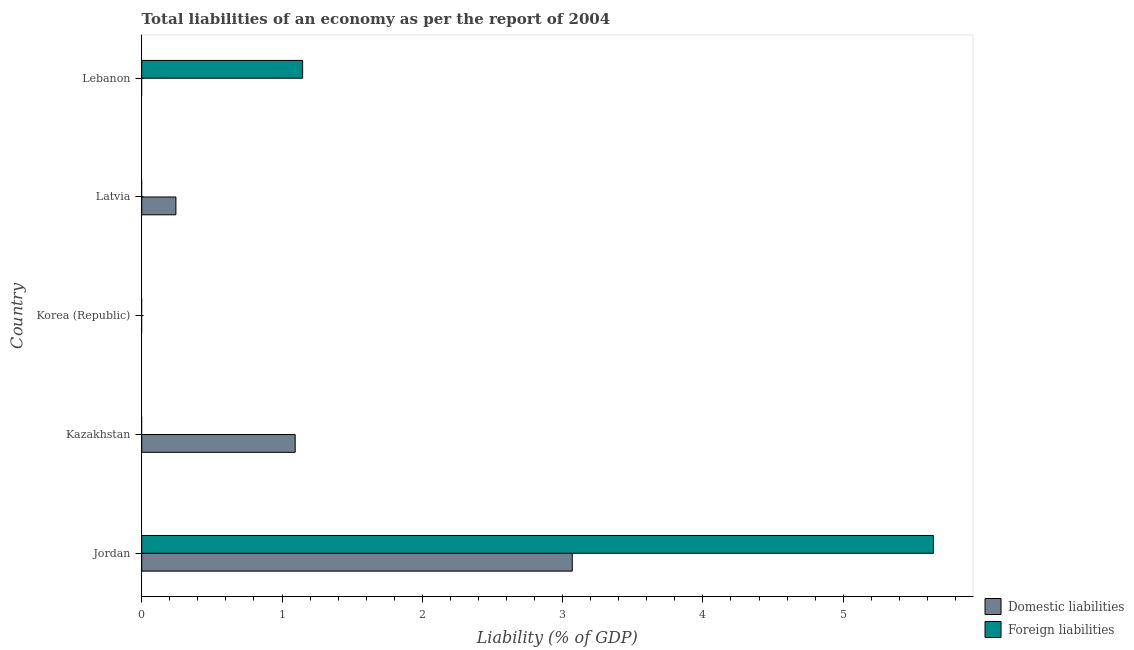How many different coloured bars are there?
Your answer should be very brief. 2. How many bars are there on the 4th tick from the top?
Make the answer very short. 1. What is the incurrence of foreign liabilities in Kazakhstan?
Offer a very short reply. 0. Across all countries, what is the maximum incurrence of foreign liabilities?
Offer a terse response. 5.64. In which country was the incurrence of domestic liabilities maximum?
Keep it short and to the point. Jordan. What is the total incurrence of foreign liabilities in the graph?
Your answer should be compact. 6.79. What is the difference between the incurrence of domestic liabilities in Jordan and that in Kazakhstan?
Your answer should be very brief. 1.98. What is the difference between the incurrence of domestic liabilities in Latvia and the incurrence of foreign liabilities in Kazakhstan?
Ensure brevity in your answer.  0.24. What is the average incurrence of foreign liabilities per country?
Provide a succinct answer. 1.36. What is the difference between the highest and the second highest incurrence of domestic liabilities?
Your answer should be very brief. 1.98. What is the difference between the highest and the lowest incurrence of foreign liabilities?
Provide a short and direct response. 5.64. In how many countries, is the incurrence of domestic liabilities greater than the average incurrence of domestic liabilities taken over all countries?
Your response must be concise. 2. How many bars are there?
Ensure brevity in your answer.  5. What is the difference between two consecutive major ticks on the X-axis?
Make the answer very short. 1. Are the values on the major ticks of X-axis written in scientific E-notation?
Make the answer very short. No. How are the legend labels stacked?
Your answer should be very brief. Vertical. What is the title of the graph?
Provide a short and direct response. Total liabilities of an economy as per the report of 2004. What is the label or title of the X-axis?
Offer a very short reply. Liability (% of GDP). What is the label or title of the Y-axis?
Provide a short and direct response. Country. What is the Liability (% of GDP) in Domestic liabilities in Jordan?
Provide a short and direct response. 3.07. What is the Liability (% of GDP) of Foreign liabilities in Jordan?
Provide a succinct answer. 5.64. What is the Liability (% of GDP) in Domestic liabilities in Kazakhstan?
Make the answer very short. 1.09. What is the Liability (% of GDP) of Domestic liabilities in Latvia?
Your response must be concise. 0.24. What is the Liability (% of GDP) of Foreign liabilities in Latvia?
Keep it short and to the point. 0. What is the Liability (% of GDP) in Domestic liabilities in Lebanon?
Ensure brevity in your answer.  0. What is the Liability (% of GDP) of Foreign liabilities in Lebanon?
Give a very brief answer. 1.15. Across all countries, what is the maximum Liability (% of GDP) of Domestic liabilities?
Provide a short and direct response. 3.07. Across all countries, what is the maximum Liability (% of GDP) of Foreign liabilities?
Your answer should be very brief. 5.64. What is the total Liability (% of GDP) in Domestic liabilities in the graph?
Offer a terse response. 4.41. What is the total Liability (% of GDP) in Foreign liabilities in the graph?
Your answer should be compact. 6.79. What is the difference between the Liability (% of GDP) of Domestic liabilities in Jordan and that in Kazakhstan?
Keep it short and to the point. 1.98. What is the difference between the Liability (% of GDP) of Domestic liabilities in Jordan and that in Latvia?
Your response must be concise. 2.83. What is the difference between the Liability (% of GDP) in Foreign liabilities in Jordan and that in Lebanon?
Provide a short and direct response. 4.5. What is the difference between the Liability (% of GDP) of Domestic liabilities in Kazakhstan and that in Latvia?
Provide a succinct answer. 0.85. What is the difference between the Liability (% of GDP) in Domestic liabilities in Jordan and the Liability (% of GDP) in Foreign liabilities in Lebanon?
Offer a terse response. 1.92. What is the difference between the Liability (% of GDP) in Domestic liabilities in Kazakhstan and the Liability (% of GDP) in Foreign liabilities in Lebanon?
Your response must be concise. -0.05. What is the difference between the Liability (% of GDP) in Domestic liabilities in Latvia and the Liability (% of GDP) in Foreign liabilities in Lebanon?
Your response must be concise. -0.9. What is the average Liability (% of GDP) in Domestic liabilities per country?
Ensure brevity in your answer.  0.88. What is the average Liability (% of GDP) in Foreign liabilities per country?
Provide a succinct answer. 1.36. What is the difference between the Liability (% of GDP) in Domestic liabilities and Liability (% of GDP) in Foreign liabilities in Jordan?
Give a very brief answer. -2.57. What is the ratio of the Liability (% of GDP) of Domestic liabilities in Jordan to that in Kazakhstan?
Offer a very short reply. 2.81. What is the ratio of the Liability (% of GDP) of Domestic liabilities in Jordan to that in Latvia?
Provide a succinct answer. 12.59. What is the ratio of the Liability (% of GDP) of Foreign liabilities in Jordan to that in Lebanon?
Give a very brief answer. 4.92. What is the ratio of the Liability (% of GDP) in Domestic liabilities in Kazakhstan to that in Latvia?
Make the answer very short. 4.49. What is the difference between the highest and the second highest Liability (% of GDP) of Domestic liabilities?
Give a very brief answer. 1.98. What is the difference between the highest and the lowest Liability (% of GDP) in Domestic liabilities?
Your response must be concise. 3.07. What is the difference between the highest and the lowest Liability (% of GDP) in Foreign liabilities?
Offer a very short reply. 5.64. 